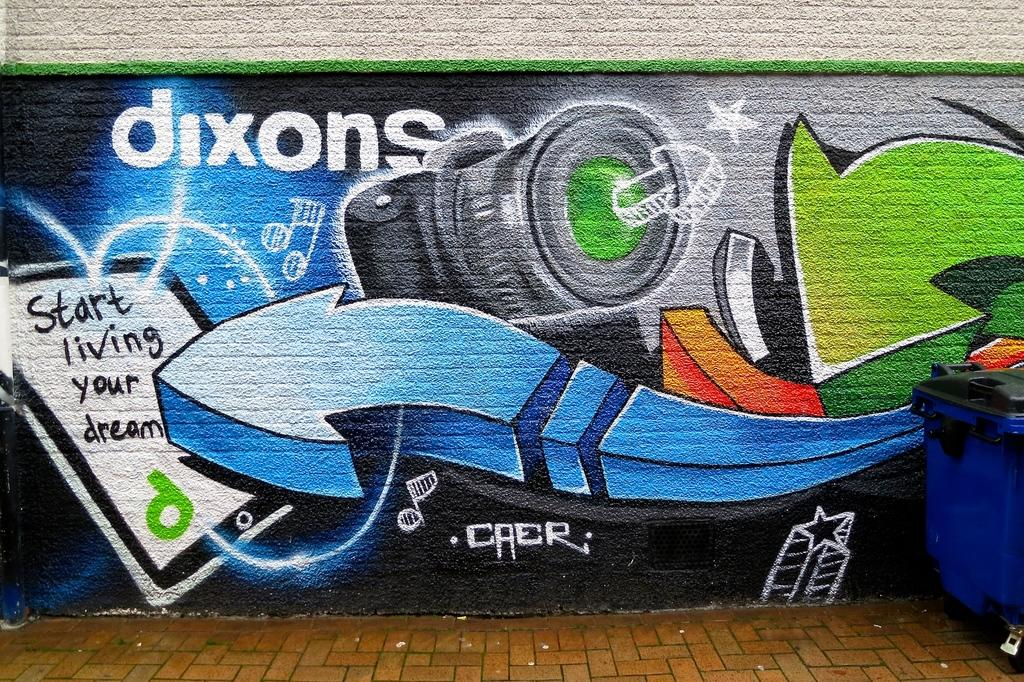<image>
Relay a brief, clear account of the picture shown. A painting on a wall has the word start painted on it. 